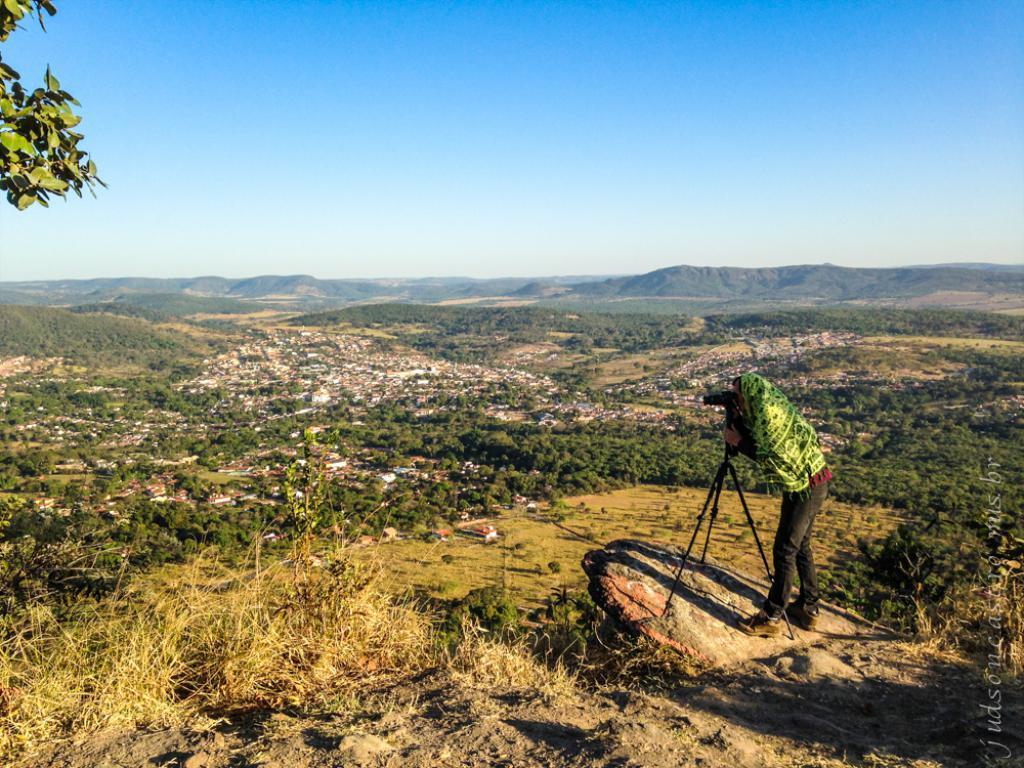Could you give a brief overview of what you see in this image? In this image we can see a person wearing red color shirt, black color jeans wrapped by a cloth which is in green color standing near the camera and in the background of the image there are some trees, houses and clear sky. 